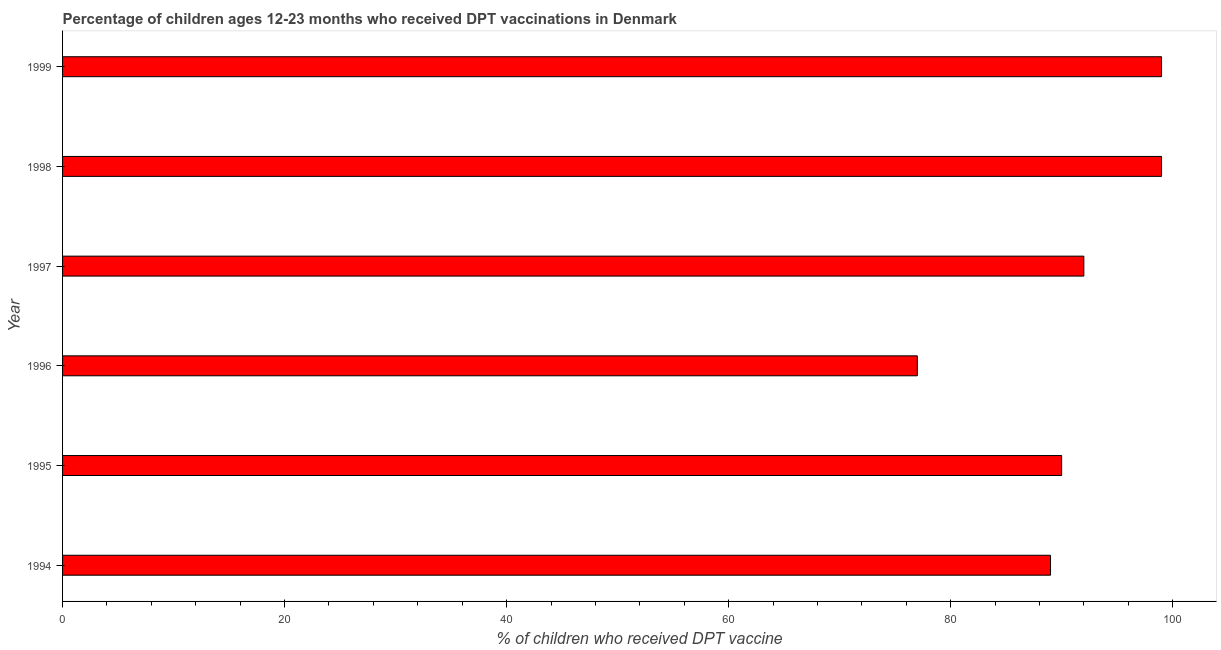Does the graph contain grids?
Make the answer very short. No. What is the title of the graph?
Provide a succinct answer. Percentage of children ages 12-23 months who received DPT vaccinations in Denmark. What is the label or title of the X-axis?
Make the answer very short. % of children who received DPT vaccine. What is the label or title of the Y-axis?
Offer a very short reply. Year. What is the percentage of children who received dpt vaccine in 1999?
Provide a short and direct response. 99. Across all years, what is the maximum percentage of children who received dpt vaccine?
Your answer should be very brief. 99. Across all years, what is the minimum percentage of children who received dpt vaccine?
Your answer should be very brief. 77. What is the sum of the percentage of children who received dpt vaccine?
Your answer should be very brief. 546. What is the difference between the percentage of children who received dpt vaccine in 1995 and 1999?
Provide a succinct answer. -9. What is the average percentage of children who received dpt vaccine per year?
Offer a very short reply. 91. What is the median percentage of children who received dpt vaccine?
Give a very brief answer. 91. Do a majority of the years between 1995 and 1996 (inclusive) have percentage of children who received dpt vaccine greater than 96 %?
Keep it short and to the point. No. What is the ratio of the percentage of children who received dpt vaccine in 1996 to that in 1998?
Offer a very short reply. 0.78. What is the difference between the highest and the second highest percentage of children who received dpt vaccine?
Your answer should be very brief. 0. Is the sum of the percentage of children who received dpt vaccine in 1998 and 1999 greater than the maximum percentage of children who received dpt vaccine across all years?
Ensure brevity in your answer.  Yes. What is the difference between the highest and the lowest percentage of children who received dpt vaccine?
Your response must be concise. 22. In how many years, is the percentage of children who received dpt vaccine greater than the average percentage of children who received dpt vaccine taken over all years?
Ensure brevity in your answer.  3. Are the values on the major ticks of X-axis written in scientific E-notation?
Provide a succinct answer. No. What is the % of children who received DPT vaccine of 1994?
Give a very brief answer. 89. What is the % of children who received DPT vaccine in 1995?
Your answer should be compact. 90. What is the % of children who received DPT vaccine in 1997?
Your answer should be very brief. 92. What is the % of children who received DPT vaccine of 1998?
Keep it short and to the point. 99. What is the % of children who received DPT vaccine of 1999?
Provide a short and direct response. 99. What is the difference between the % of children who received DPT vaccine in 1994 and 1996?
Ensure brevity in your answer.  12. What is the difference between the % of children who received DPT vaccine in 1994 and 1998?
Provide a succinct answer. -10. What is the difference between the % of children who received DPT vaccine in 1995 and 1996?
Your answer should be very brief. 13. What is the difference between the % of children who received DPT vaccine in 1995 and 1998?
Offer a terse response. -9. What is the difference between the % of children who received DPT vaccine in 1995 and 1999?
Offer a terse response. -9. What is the difference between the % of children who received DPT vaccine in 1996 and 1997?
Your answer should be very brief. -15. What is the difference between the % of children who received DPT vaccine in 1996 and 1998?
Offer a terse response. -22. What is the difference between the % of children who received DPT vaccine in 1996 and 1999?
Offer a terse response. -22. What is the difference between the % of children who received DPT vaccine in 1997 and 1998?
Make the answer very short. -7. What is the difference between the % of children who received DPT vaccine in 1998 and 1999?
Provide a succinct answer. 0. What is the ratio of the % of children who received DPT vaccine in 1994 to that in 1995?
Provide a succinct answer. 0.99. What is the ratio of the % of children who received DPT vaccine in 1994 to that in 1996?
Offer a very short reply. 1.16. What is the ratio of the % of children who received DPT vaccine in 1994 to that in 1997?
Your response must be concise. 0.97. What is the ratio of the % of children who received DPT vaccine in 1994 to that in 1998?
Provide a succinct answer. 0.9. What is the ratio of the % of children who received DPT vaccine in 1994 to that in 1999?
Ensure brevity in your answer.  0.9. What is the ratio of the % of children who received DPT vaccine in 1995 to that in 1996?
Provide a succinct answer. 1.17. What is the ratio of the % of children who received DPT vaccine in 1995 to that in 1997?
Your answer should be very brief. 0.98. What is the ratio of the % of children who received DPT vaccine in 1995 to that in 1998?
Your response must be concise. 0.91. What is the ratio of the % of children who received DPT vaccine in 1995 to that in 1999?
Keep it short and to the point. 0.91. What is the ratio of the % of children who received DPT vaccine in 1996 to that in 1997?
Keep it short and to the point. 0.84. What is the ratio of the % of children who received DPT vaccine in 1996 to that in 1998?
Your answer should be very brief. 0.78. What is the ratio of the % of children who received DPT vaccine in 1996 to that in 1999?
Ensure brevity in your answer.  0.78. What is the ratio of the % of children who received DPT vaccine in 1997 to that in 1998?
Make the answer very short. 0.93. What is the ratio of the % of children who received DPT vaccine in 1997 to that in 1999?
Your answer should be very brief. 0.93. 